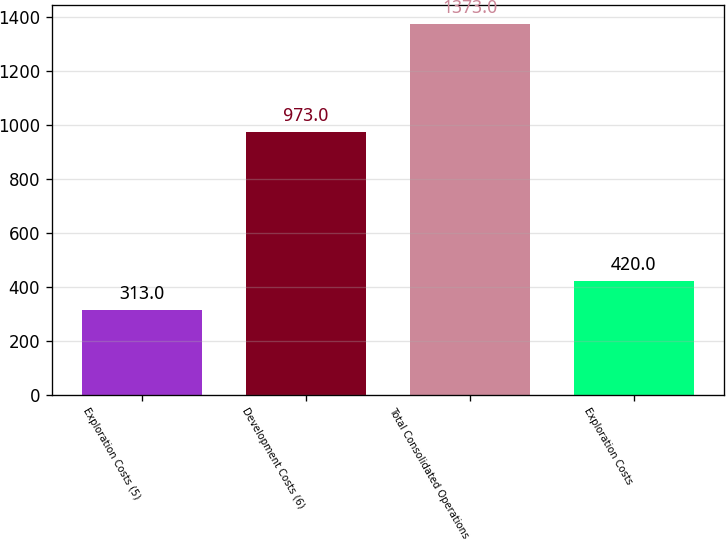Convert chart. <chart><loc_0><loc_0><loc_500><loc_500><bar_chart><fcel>Exploration Costs (5)<fcel>Development Costs (6)<fcel>Total Consolidated Operations<fcel>Exploration Costs<nl><fcel>313<fcel>973<fcel>1373<fcel>420<nl></chart> 